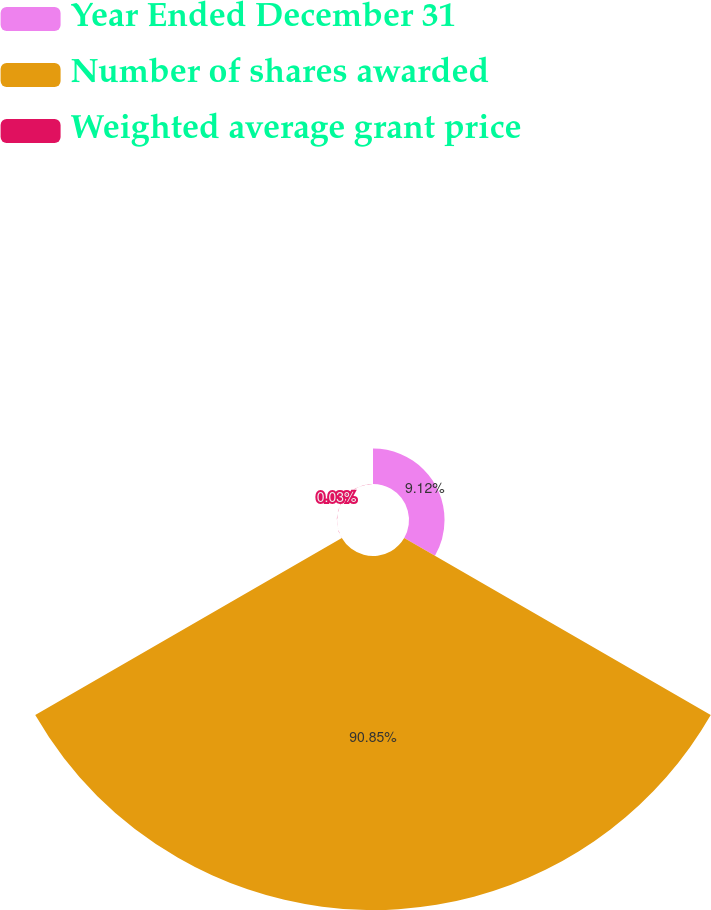Convert chart. <chart><loc_0><loc_0><loc_500><loc_500><pie_chart><fcel>Year Ended December 31<fcel>Number of shares awarded<fcel>Weighted average grant price<nl><fcel>9.12%<fcel>90.85%<fcel>0.03%<nl></chart> 